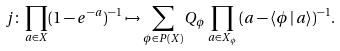Convert formula to latex. <formula><loc_0><loc_0><loc_500><loc_500>j \colon \prod _ { a \in X } ( 1 - e ^ { - a } ) ^ { - 1 } \mapsto \sum _ { \phi \in P ( X ) } Q _ { \phi } \prod _ { a \in X _ { \phi } } \, ( a - \langle \phi \, | \, a \rangle ) ^ { - 1 } .</formula> 